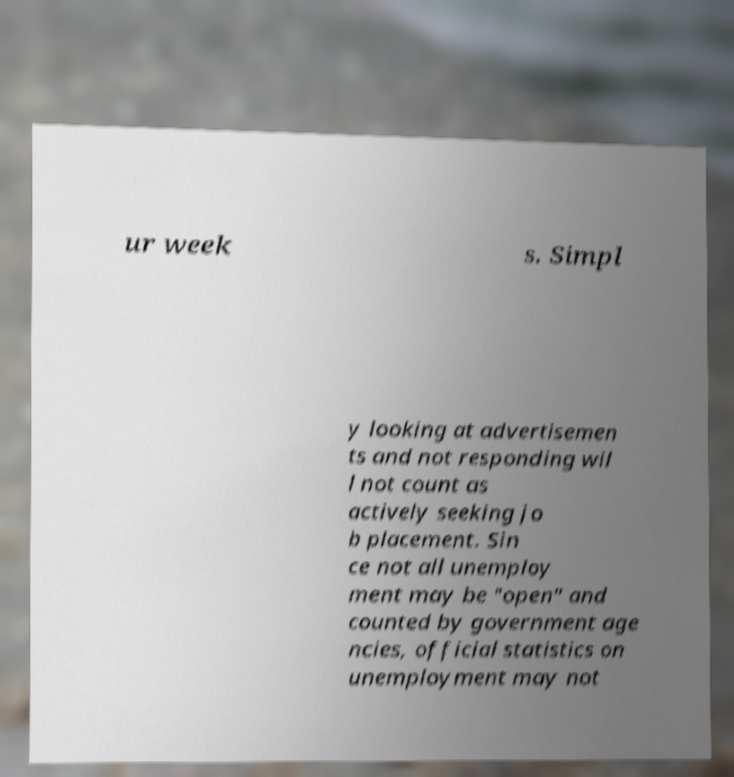Could you extract and type out the text from this image? ur week s. Simpl y looking at advertisemen ts and not responding wil l not count as actively seeking jo b placement. Sin ce not all unemploy ment may be "open" and counted by government age ncies, official statistics on unemployment may not 